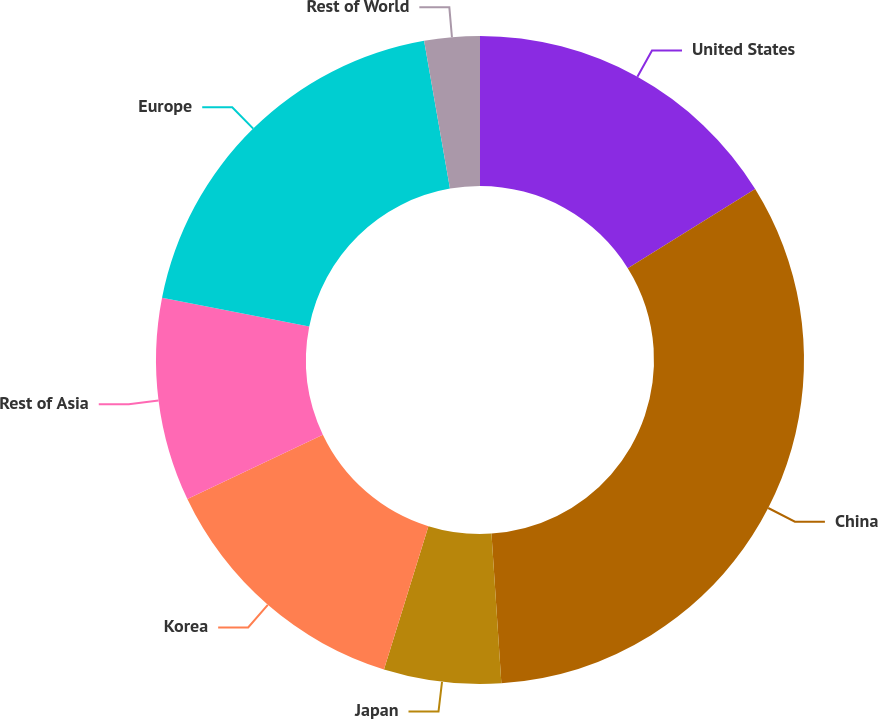<chart> <loc_0><loc_0><loc_500><loc_500><pie_chart><fcel>United States<fcel>China<fcel>Japan<fcel>Korea<fcel>Rest of Asia<fcel>Europe<fcel>Rest of World<nl><fcel>16.15%<fcel>32.8%<fcel>5.84%<fcel>13.15%<fcel>10.14%<fcel>19.16%<fcel>2.76%<nl></chart> 